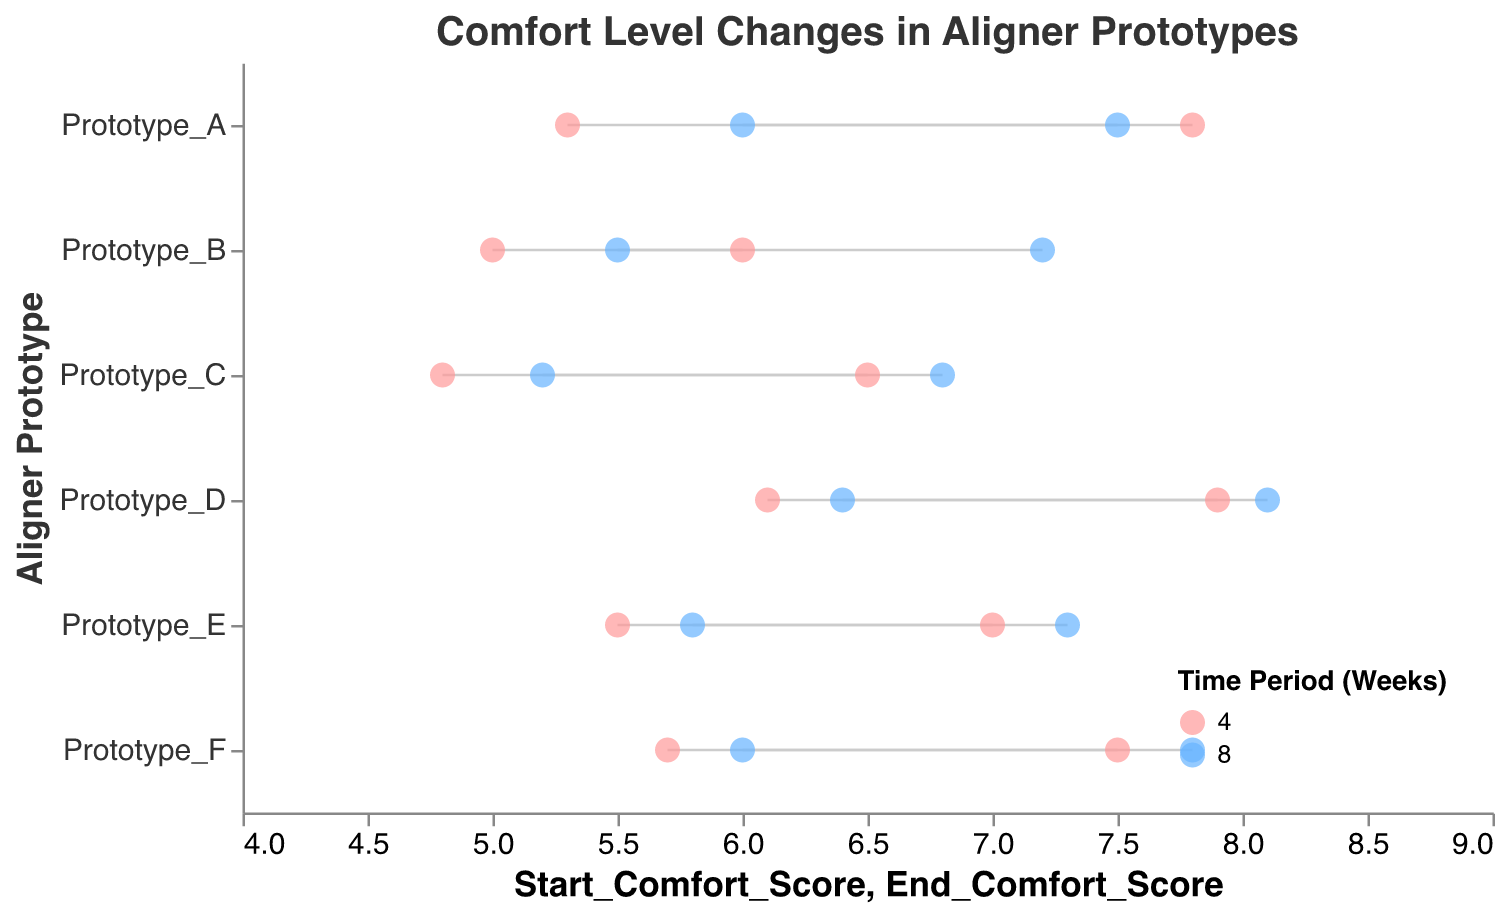Which prototype has the highest final comfort score after 8 weeks? Look at the data points marked with a time period of 8 weeks and compare their end comfort scores. Prototype D has the highest final comfort score of 8.1.
Answer: Prototype D What's the average increase in comfort score for Prototype C from the start to the end over both time periods? Calculate the increase for each time period: (6.5 - 4.8) = 1.7 and (6.8 - 5.2) = 1.6. Then average these two values: (1.7 + 1.6) / 2 = 1.65.
Answer: 1.65 Which prototype had the smallest improvement in comfort over the 4-week period? Compare the comfort score increases for the 4-week periods: Prototype A (2.5), Prototype B (1.0), Prototype C (1.7), Prototype D (1.8), Prototype E (1.5), Prototype F (1.8). Prototype B had the smallest improvement with an increase of 1.0.
Answer: Prototype B How does the initial comfort score of Prototype E compare with the initial comfort score of Prototype F in the 8-week period? Compare the initial comfort scores for both prototypes at 8 weeks: Prototype E is 5.8; Prototype F is 6.0. Prototype F has a higher initial comfort score.
Answer: Prototype F What is the maximum increase in comfort score observed across all prototypes over the 8-week period? Calculate the increase in comfort scores for the 8-week period for all prototypes: Prototype A (7.5 - 6.0 = 1.5), Prototype B (7.2 - 5.5 = 1.7), Prototype C (6.8 - 5.2 = 1.6), Prototype D (8.1 - 6.4 = 1.7), Prototype E (7.3 - 5.8 = 1.5), Prototype F (7.8 - 6.0 = 1.8). The maximum increase is 1.8 seen in Prototype F.
Answer: 1.8 Which prototypes show a higher end comfort score consistently at both 4 and 8 weeks? Look for prototypes that maintain higher end comfort scores consistently at both time periods: Possible candidates are Prototype A, Prototype D, and Prototype F. Prototype D and F stay higher throughout.
Answer: Prototype D, Prototype F Which time period color represents 4 weeks? Identify the color associated with the 4-week time period from the plot legend: 4 weeks is colored in red tones (#ff9999).
Answer: Red tones How does the start comfort score comparison between Prototype A and Prototype C change over 4 and 8 weeks? Compare start comfort scores: For 4 weeks, Prototype A (5.3) is higher than Prototype C (4.8). For 8 weeks, Prototype A (6.0) is higher than Prototype C (5.2). The start comfort score for Prototype A is consistently higher.
Answer: Prototype A consistently higher What is the total number of data points represented in the plot? Count the number of rows in the data table, which corresponds to the number of data points in the plot: 12 data points.
Answer: 12 